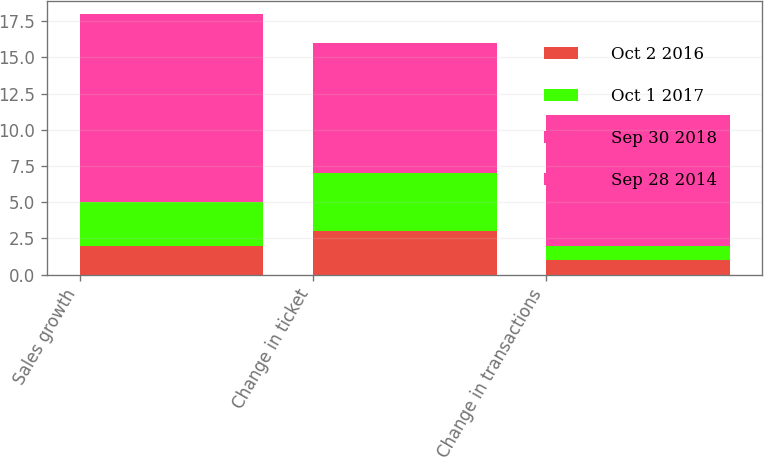Convert chart. <chart><loc_0><loc_0><loc_500><loc_500><stacked_bar_chart><ecel><fcel>Sales growth<fcel>Change in ticket<fcel>Change in transactions<nl><fcel>Oct 2 2016<fcel>2<fcel>3<fcel>1<nl><fcel>Oct 1 2017<fcel>3<fcel>4<fcel>1<nl><fcel>Sep 30 2018<fcel>6<fcel>5<fcel>1<nl><fcel>Sep 28 2014<fcel>7<fcel>4<fcel>8<nl></chart> 